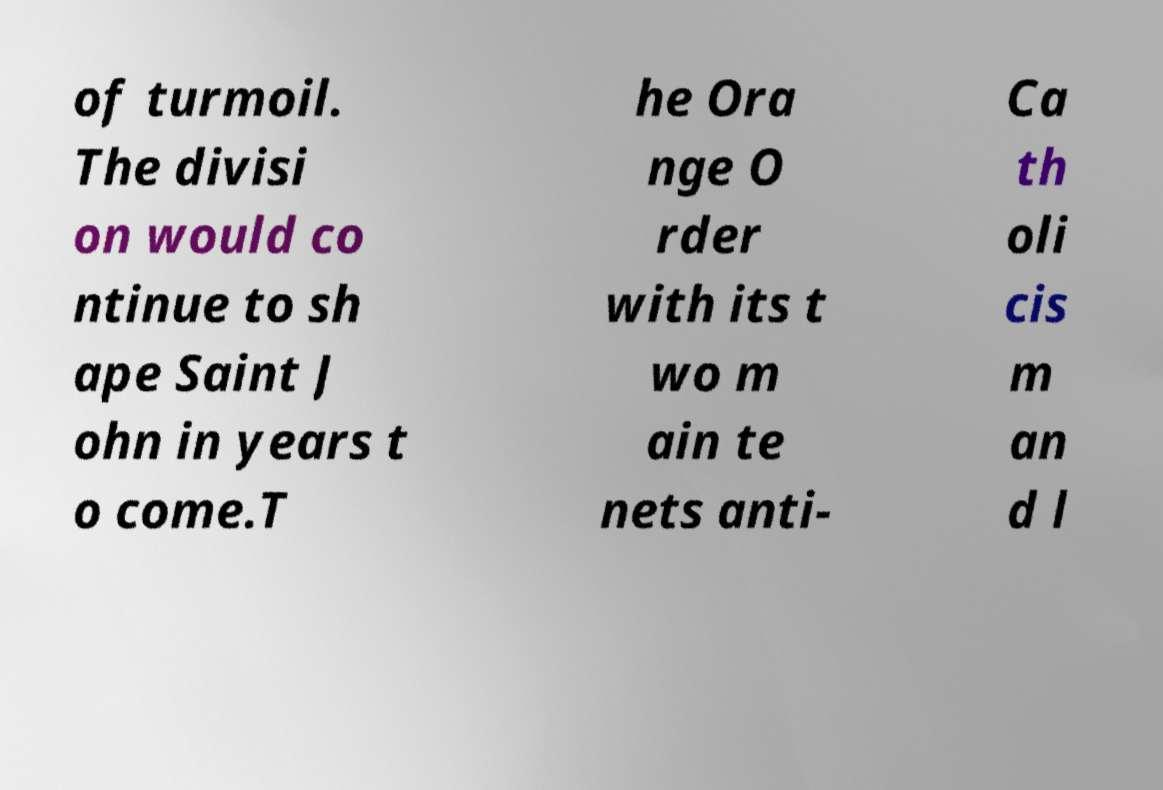Can you read and provide the text displayed in the image?This photo seems to have some interesting text. Can you extract and type it out for me? of turmoil. The divisi on would co ntinue to sh ape Saint J ohn in years t o come.T he Ora nge O rder with its t wo m ain te nets anti- Ca th oli cis m an d l 